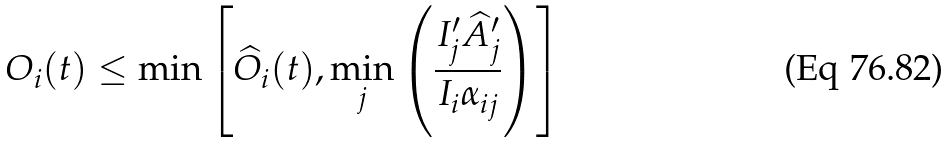<formula> <loc_0><loc_0><loc_500><loc_500>O _ { i } ( t ) \leq \min \left [ \widehat { O } _ { i } ( t ) , \min _ { j } \left ( \frac { I ^ { \prime } _ { j } \widehat { A } ^ { \prime } _ { j } } { I _ { i } \alpha _ { i j } } \right ) \right ]</formula> 